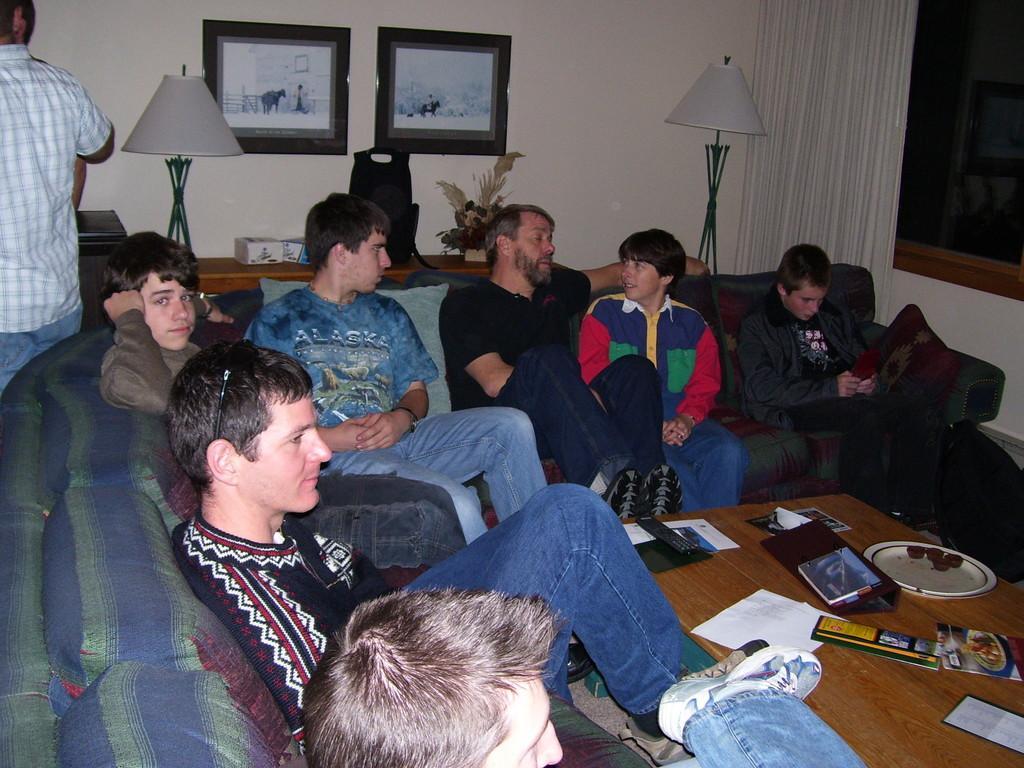Please provide a concise description of this image. In this picture, we can see a few people sitting on sofa and among them one person is standing, and we can see the wall with some objects like photo frames, windows, curtain, we can see lamps with poles, we can see desk and some objects on it, table and some objects on it like plate, and papers. 